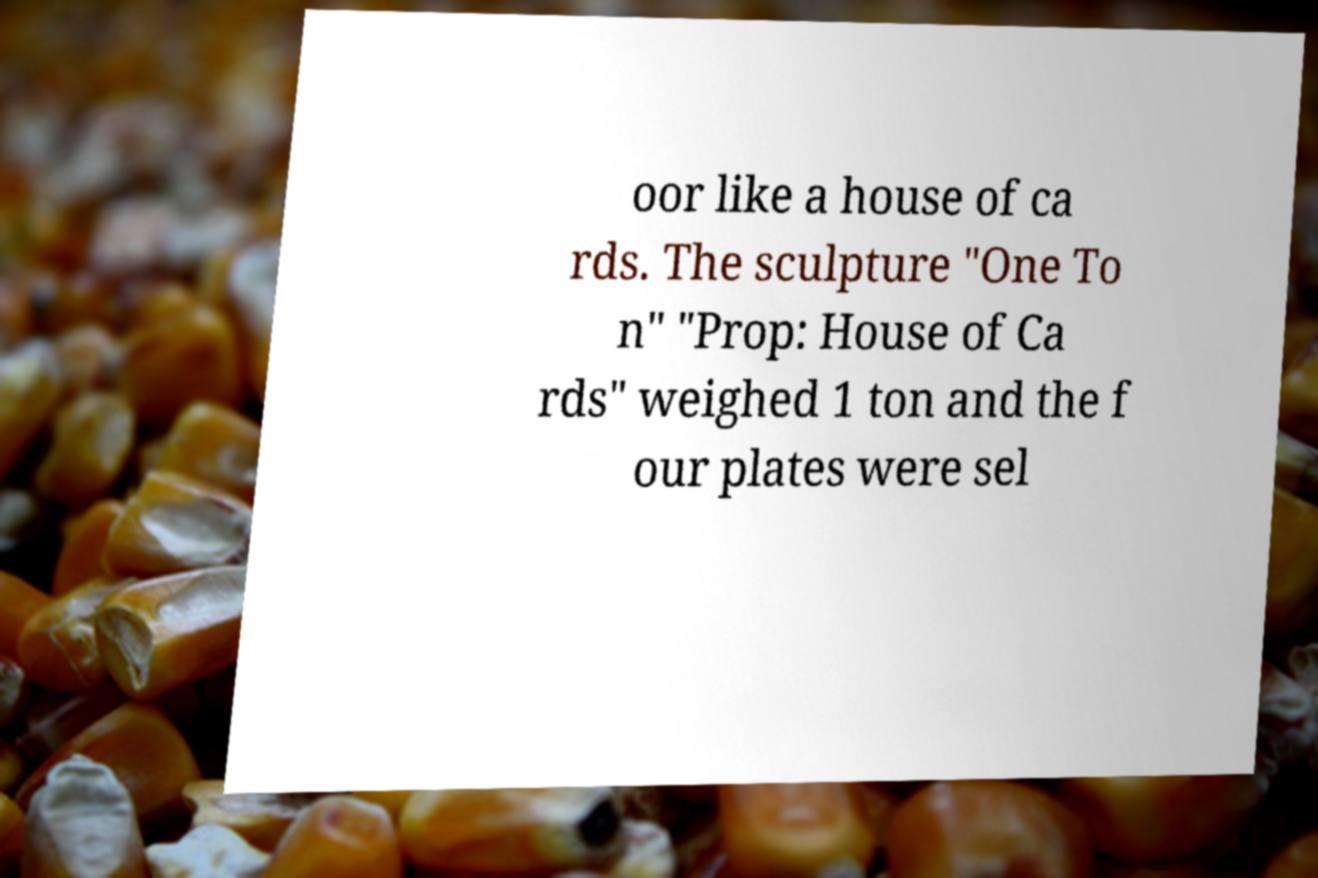Could you assist in decoding the text presented in this image and type it out clearly? oor like a house of ca rds. The sculpture "One To n" "Prop: House of Ca rds" weighed 1 ton and the f our plates were sel 